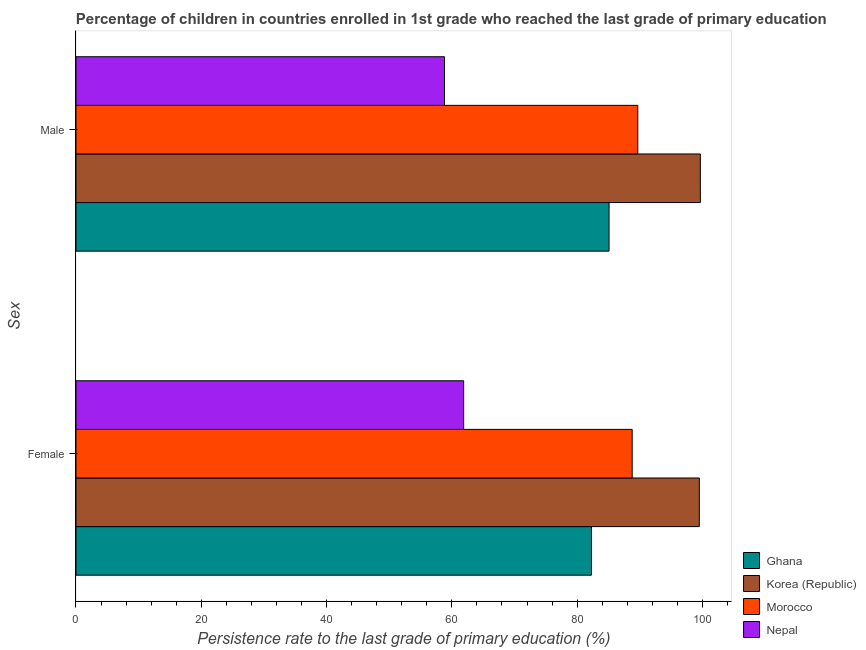How many bars are there on the 2nd tick from the top?
Offer a terse response. 4. What is the label of the 2nd group of bars from the top?
Ensure brevity in your answer.  Female. What is the persistence rate of female students in Korea (Republic)?
Provide a short and direct response. 99.51. Across all countries, what is the maximum persistence rate of female students?
Your answer should be compact. 99.51. Across all countries, what is the minimum persistence rate of male students?
Your response must be concise. 58.83. In which country was the persistence rate of male students maximum?
Your answer should be very brief. Korea (Republic). In which country was the persistence rate of male students minimum?
Your answer should be compact. Nepal. What is the total persistence rate of male students in the graph?
Make the answer very short. 333.28. What is the difference between the persistence rate of male students in Morocco and that in Korea (Republic)?
Your response must be concise. -9.98. What is the difference between the persistence rate of female students in Ghana and the persistence rate of male students in Morocco?
Make the answer very short. -7.4. What is the average persistence rate of male students per country?
Offer a terse response. 83.32. What is the difference between the persistence rate of male students and persistence rate of female students in Morocco?
Provide a succinct answer. 0.89. In how many countries, is the persistence rate of female students greater than 80 %?
Your answer should be very brief. 3. What is the ratio of the persistence rate of female students in Morocco to that in Korea (Republic)?
Keep it short and to the point. 0.89. Is the persistence rate of female students in Nepal less than that in Ghana?
Make the answer very short. Yes. What does the 2nd bar from the top in Female represents?
Offer a very short reply. Morocco. What does the 4th bar from the bottom in Male represents?
Your answer should be very brief. Nepal. How many bars are there?
Your response must be concise. 8. How many countries are there in the graph?
Give a very brief answer. 4. Are the values on the major ticks of X-axis written in scientific E-notation?
Ensure brevity in your answer.  No. How many legend labels are there?
Provide a succinct answer. 4. How are the legend labels stacked?
Make the answer very short. Vertical. What is the title of the graph?
Offer a very short reply. Percentage of children in countries enrolled in 1st grade who reached the last grade of primary education. What is the label or title of the X-axis?
Offer a very short reply. Persistence rate to the last grade of primary education (%). What is the label or title of the Y-axis?
Offer a very short reply. Sex. What is the Persistence rate to the last grade of primary education (%) of Ghana in Female?
Provide a succinct answer. 82.29. What is the Persistence rate to the last grade of primary education (%) in Korea (Republic) in Female?
Your answer should be very brief. 99.51. What is the Persistence rate to the last grade of primary education (%) in Morocco in Female?
Your response must be concise. 88.79. What is the Persistence rate to the last grade of primary education (%) of Nepal in Female?
Ensure brevity in your answer.  61.89. What is the Persistence rate to the last grade of primary education (%) in Ghana in Male?
Provide a succinct answer. 85.1. What is the Persistence rate to the last grade of primary education (%) of Korea (Republic) in Male?
Your answer should be compact. 99.67. What is the Persistence rate to the last grade of primary education (%) of Morocco in Male?
Ensure brevity in your answer.  89.69. What is the Persistence rate to the last grade of primary education (%) in Nepal in Male?
Keep it short and to the point. 58.83. Across all Sex, what is the maximum Persistence rate to the last grade of primary education (%) in Ghana?
Provide a succinct answer. 85.1. Across all Sex, what is the maximum Persistence rate to the last grade of primary education (%) of Korea (Republic)?
Offer a very short reply. 99.67. Across all Sex, what is the maximum Persistence rate to the last grade of primary education (%) in Morocco?
Ensure brevity in your answer.  89.69. Across all Sex, what is the maximum Persistence rate to the last grade of primary education (%) in Nepal?
Provide a succinct answer. 61.89. Across all Sex, what is the minimum Persistence rate to the last grade of primary education (%) in Ghana?
Ensure brevity in your answer.  82.29. Across all Sex, what is the minimum Persistence rate to the last grade of primary education (%) in Korea (Republic)?
Your response must be concise. 99.51. Across all Sex, what is the minimum Persistence rate to the last grade of primary education (%) of Morocco?
Make the answer very short. 88.79. Across all Sex, what is the minimum Persistence rate to the last grade of primary education (%) of Nepal?
Keep it short and to the point. 58.83. What is the total Persistence rate to the last grade of primary education (%) in Ghana in the graph?
Offer a very short reply. 167.39. What is the total Persistence rate to the last grade of primary education (%) in Korea (Republic) in the graph?
Ensure brevity in your answer.  199.18. What is the total Persistence rate to the last grade of primary education (%) of Morocco in the graph?
Your answer should be very brief. 178.48. What is the total Persistence rate to the last grade of primary education (%) in Nepal in the graph?
Provide a short and direct response. 120.72. What is the difference between the Persistence rate to the last grade of primary education (%) of Ghana in Female and that in Male?
Give a very brief answer. -2.81. What is the difference between the Persistence rate to the last grade of primary education (%) of Korea (Republic) in Female and that in Male?
Make the answer very short. -0.16. What is the difference between the Persistence rate to the last grade of primary education (%) of Morocco in Female and that in Male?
Make the answer very short. -0.9. What is the difference between the Persistence rate to the last grade of primary education (%) of Nepal in Female and that in Male?
Give a very brief answer. 3.06. What is the difference between the Persistence rate to the last grade of primary education (%) of Ghana in Female and the Persistence rate to the last grade of primary education (%) of Korea (Republic) in Male?
Ensure brevity in your answer.  -17.38. What is the difference between the Persistence rate to the last grade of primary education (%) in Ghana in Female and the Persistence rate to the last grade of primary education (%) in Morocco in Male?
Your answer should be very brief. -7.4. What is the difference between the Persistence rate to the last grade of primary education (%) of Ghana in Female and the Persistence rate to the last grade of primary education (%) of Nepal in Male?
Your response must be concise. 23.46. What is the difference between the Persistence rate to the last grade of primary education (%) in Korea (Republic) in Female and the Persistence rate to the last grade of primary education (%) in Morocco in Male?
Offer a very short reply. 9.82. What is the difference between the Persistence rate to the last grade of primary education (%) of Korea (Republic) in Female and the Persistence rate to the last grade of primary education (%) of Nepal in Male?
Keep it short and to the point. 40.68. What is the difference between the Persistence rate to the last grade of primary education (%) in Morocco in Female and the Persistence rate to the last grade of primary education (%) in Nepal in Male?
Give a very brief answer. 29.97. What is the average Persistence rate to the last grade of primary education (%) of Ghana per Sex?
Your answer should be compact. 83.69. What is the average Persistence rate to the last grade of primary education (%) of Korea (Republic) per Sex?
Provide a succinct answer. 99.59. What is the average Persistence rate to the last grade of primary education (%) of Morocco per Sex?
Make the answer very short. 89.24. What is the average Persistence rate to the last grade of primary education (%) in Nepal per Sex?
Your response must be concise. 60.36. What is the difference between the Persistence rate to the last grade of primary education (%) in Ghana and Persistence rate to the last grade of primary education (%) in Korea (Republic) in Female?
Offer a terse response. -17.22. What is the difference between the Persistence rate to the last grade of primary education (%) in Ghana and Persistence rate to the last grade of primary education (%) in Morocco in Female?
Offer a terse response. -6.5. What is the difference between the Persistence rate to the last grade of primary education (%) in Ghana and Persistence rate to the last grade of primary education (%) in Nepal in Female?
Keep it short and to the point. 20.4. What is the difference between the Persistence rate to the last grade of primary education (%) in Korea (Republic) and Persistence rate to the last grade of primary education (%) in Morocco in Female?
Provide a short and direct response. 10.72. What is the difference between the Persistence rate to the last grade of primary education (%) of Korea (Republic) and Persistence rate to the last grade of primary education (%) of Nepal in Female?
Give a very brief answer. 37.62. What is the difference between the Persistence rate to the last grade of primary education (%) in Morocco and Persistence rate to the last grade of primary education (%) in Nepal in Female?
Keep it short and to the point. 26.9. What is the difference between the Persistence rate to the last grade of primary education (%) of Ghana and Persistence rate to the last grade of primary education (%) of Korea (Republic) in Male?
Ensure brevity in your answer.  -14.57. What is the difference between the Persistence rate to the last grade of primary education (%) of Ghana and Persistence rate to the last grade of primary education (%) of Morocco in Male?
Ensure brevity in your answer.  -4.59. What is the difference between the Persistence rate to the last grade of primary education (%) of Ghana and Persistence rate to the last grade of primary education (%) of Nepal in Male?
Provide a short and direct response. 26.27. What is the difference between the Persistence rate to the last grade of primary education (%) in Korea (Republic) and Persistence rate to the last grade of primary education (%) in Morocco in Male?
Provide a short and direct response. 9.98. What is the difference between the Persistence rate to the last grade of primary education (%) in Korea (Republic) and Persistence rate to the last grade of primary education (%) in Nepal in Male?
Your answer should be very brief. 40.84. What is the difference between the Persistence rate to the last grade of primary education (%) in Morocco and Persistence rate to the last grade of primary education (%) in Nepal in Male?
Your answer should be compact. 30.86. What is the ratio of the Persistence rate to the last grade of primary education (%) in Morocco in Female to that in Male?
Offer a very short reply. 0.99. What is the ratio of the Persistence rate to the last grade of primary education (%) of Nepal in Female to that in Male?
Offer a terse response. 1.05. What is the difference between the highest and the second highest Persistence rate to the last grade of primary education (%) in Ghana?
Offer a very short reply. 2.81. What is the difference between the highest and the second highest Persistence rate to the last grade of primary education (%) of Korea (Republic)?
Offer a very short reply. 0.16. What is the difference between the highest and the second highest Persistence rate to the last grade of primary education (%) of Morocco?
Your answer should be compact. 0.9. What is the difference between the highest and the second highest Persistence rate to the last grade of primary education (%) in Nepal?
Your answer should be very brief. 3.06. What is the difference between the highest and the lowest Persistence rate to the last grade of primary education (%) of Ghana?
Provide a succinct answer. 2.81. What is the difference between the highest and the lowest Persistence rate to the last grade of primary education (%) of Korea (Republic)?
Provide a succinct answer. 0.16. What is the difference between the highest and the lowest Persistence rate to the last grade of primary education (%) in Morocco?
Your answer should be very brief. 0.9. What is the difference between the highest and the lowest Persistence rate to the last grade of primary education (%) of Nepal?
Keep it short and to the point. 3.06. 